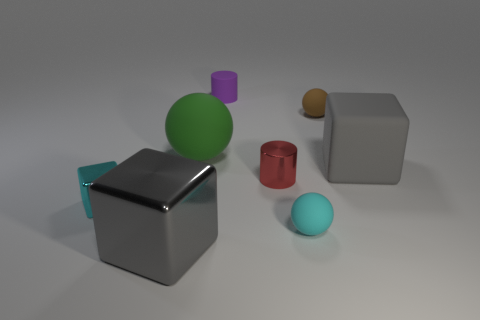Subtract all tiny cyan cubes. How many cubes are left? 2 Add 1 green matte things. How many objects exist? 9 Subtract all brown spheres. How many spheres are left? 2 Subtract 3 balls. How many balls are left? 0 Subtract 1 cyan spheres. How many objects are left? 7 Subtract all blocks. How many objects are left? 5 Subtract all yellow balls. Subtract all gray cylinders. How many balls are left? 3 Subtract all red cubes. How many red balls are left? 0 Subtract all small blocks. Subtract all rubber things. How many objects are left? 2 Add 4 metal blocks. How many metal blocks are left? 6 